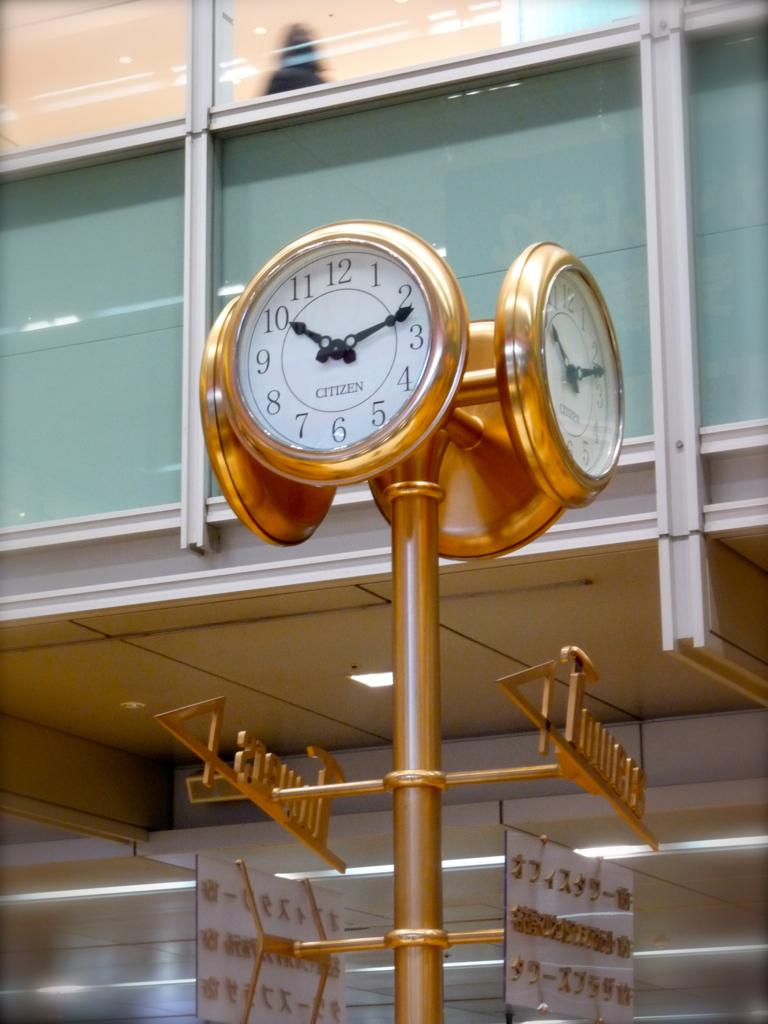<image>
Summarize the visual content of the image. A gold colored Citizen clock with four faces shows the time. 